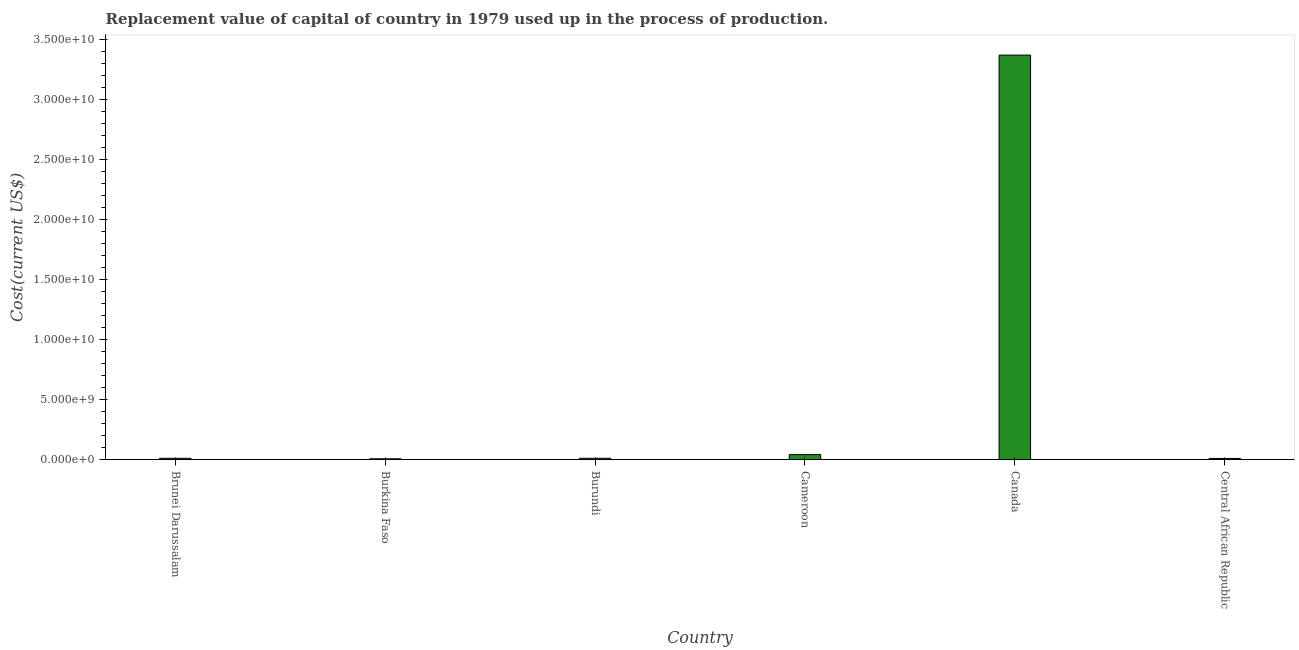Does the graph contain any zero values?
Provide a short and direct response. No. What is the title of the graph?
Your answer should be very brief. Replacement value of capital of country in 1979 used up in the process of production. What is the label or title of the Y-axis?
Ensure brevity in your answer.  Cost(current US$). What is the consumption of fixed capital in Brunei Darussalam?
Your answer should be compact. 1.16e+08. Across all countries, what is the maximum consumption of fixed capital?
Offer a very short reply. 3.37e+1. Across all countries, what is the minimum consumption of fixed capital?
Ensure brevity in your answer.  7.49e+07. In which country was the consumption of fixed capital minimum?
Give a very brief answer. Burkina Faso. What is the sum of the consumption of fixed capital?
Ensure brevity in your answer.  3.45e+1. What is the difference between the consumption of fixed capital in Burundi and Central African Republic?
Your answer should be compact. 1.46e+07. What is the average consumption of fixed capital per country?
Give a very brief answer. 5.76e+09. What is the median consumption of fixed capital?
Provide a succinct answer. 1.17e+08. What is the ratio of the consumption of fixed capital in Burundi to that in Cameroon?
Make the answer very short. 0.28. Is the consumption of fixed capital in Brunei Darussalam less than that in Burkina Faso?
Ensure brevity in your answer.  No. Is the difference between the consumption of fixed capital in Burkina Faso and Canada greater than the difference between any two countries?
Your answer should be very brief. Yes. What is the difference between the highest and the second highest consumption of fixed capital?
Offer a terse response. 3.33e+1. Is the sum of the consumption of fixed capital in Brunei Darussalam and Central African Republic greater than the maximum consumption of fixed capital across all countries?
Provide a short and direct response. No. What is the difference between the highest and the lowest consumption of fixed capital?
Ensure brevity in your answer.  3.36e+1. How many countries are there in the graph?
Provide a succinct answer. 6. What is the difference between two consecutive major ticks on the Y-axis?
Provide a short and direct response. 5.00e+09. What is the Cost(current US$) in Brunei Darussalam?
Make the answer very short. 1.16e+08. What is the Cost(current US$) in Burkina Faso?
Give a very brief answer. 7.49e+07. What is the Cost(current US$) of Burundi?
Offer a very short reply. 1.18e+08. What is the Cost(current US$) in Cameroon?
Offer a terse response. 4.25e+08. What is the Cost(current US$) of Canada?
Your answer should be very brief. 3.37e+1. What is the Cost(current US$) in Central African Republic?
Offer a terse response. 1.04e+08. What is the difference between the Cost(current US$) in Brunei Darussalam and Burkina Faso?
Offer a very short reply. 4.10e+07. What is the difference between the Cost(current US$) in Brunei Darussalam and Burundi?
Provide a short and direct response. -2.52e+06. What is the difference between the Cost(current US$) in Brunei Darussalam and Cameroon?
Offer a very short reply. -3.09e+08. What is the difference between the Cost(current US$) in Brunei Darussalam and Canada?
Provide a short and direct response. -3.36e+1. What is the difference between the Cost(current US$) in Brunei Darussalam and Central African Republic?
Offer a terse response. 1.21e+07. What is the difference between the Cost(current US$) in Burkina Faso and Burundi?
Offer a very short reply. -4.35e+07. What is the difference between the Cost(current US$) in Burkina Faso and Cameroon?
Ensure brevity in your answer.  -3.50e+08. What is the difference between the Cost(current US$) in Burkina Faso and Canada?
Your answer should be very brief. -3.36e+1. What is the difference between the Cost(current US$) in Burkina Faso and Central African Republic?
Make the answer very short. -2.89e+07. What is the difference between the Cost(current US$) in Burundi and Cameroon?
Ensure brevity in your answer.  -3.06e+08. What is the difference between the Cost(current US$) in Burundi and Canada?
Provide a succinct answer. -3.36e+1. What is the difference between the Cost(current US$) in Burundi and Central African Republic?
Make the answer very short. 1.46e+07. What is the difference between the Cost(current US$) in Cameroon and Canada?
Provide a short and direct response. -3.33e+1. What is the difference between the Cost(current US$) in Cameroon and Central African Republic?
Give a very brief answer. 3.21e+08. What is the difference between the Cost(current US$) in Canada and Central African Republic?
Offer a terse response. 3.36e+1. What is the ratio of the Cost(current US$) in Brunei Darussalam to that in Burkina Faso?
Offer a very short reply. 1.55. What is the ratio of the Cost(current US$) in Brunei Darussalam to that in Cameroon?
Keep it short and to the point. 0.27. What is the ratio of the Cost(current US$) in Brunei Darussalam to that in Canada?
Provide a succinct answer. 0. What is the ratio of the Cost(current US$) in Brunei Darussalam to that in Central African Republic?
Provide a short and direct response. 1.12. What is the ratio of the Cost(current US$) in Burkina Faso to that in Burundi?
Provide a short and direct response. 0.63. What is the ratio of the Cost(current US$) in Burkina Faso to that in Cameroon?
Your response must be concise. 0.18. What is the ratio of the Cost(current US$) in Burkina Faso to that in Canada?
Give a very brief answer. 0. What is the ratio of the Cost(current US$) in Burkina Faso to that in Central African Republic?
Offer a very short reply. 0.72. What is the ratio of the Cost(current US$) in Burundi to that in Cameroon?
Provide a succinct answer. 0.28. What is the ratio of the Cost(current US$) in Burundi to that in Canada?
Provide a succinct answer. 0. What is the ratio of the Cost(current US$) in Burundi to that in Central African Republic?
Give a very brief answer. 1.14. What is the ratio of the Cost(current US$) in Cameroon to that in Canada?
Provide a succinct answer. 0.01. What is the ratio of the Cost(current US$) in Cameroon to that in Central African Republic?
Make the answer very short. 4.09. What is the ratio of the Cost(current US$) in Canada to that in Central African Republic?
Your answer should be compact. 324.71. 